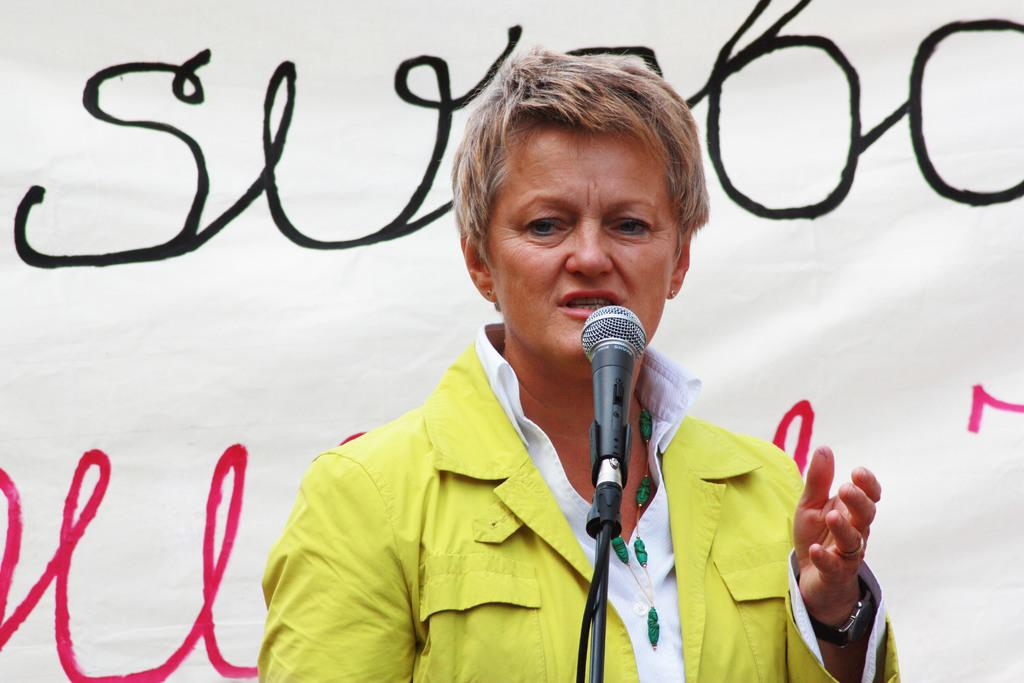Who or what is the main subject of the image? There is a person in the image. What is the person doing in the image? The person is standing in front of a microphone. What can be seen in the background of the image? There is a banner visible in the background of the image. What type of collar can be seen on the sheep in the image? There are no sheep or collars present in the image; it features a person standing in front of a microphone with a banner in the background. 